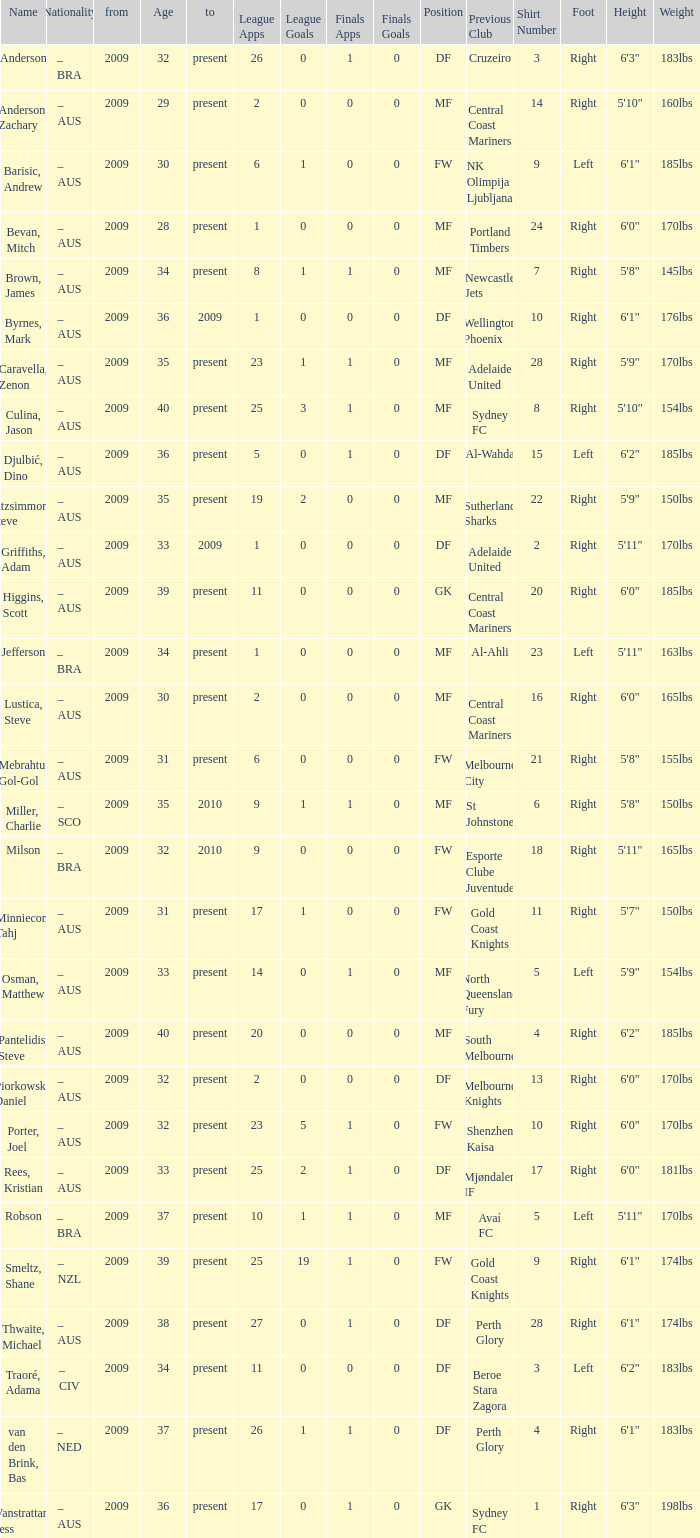Name the position for van den brink, bas DF. 